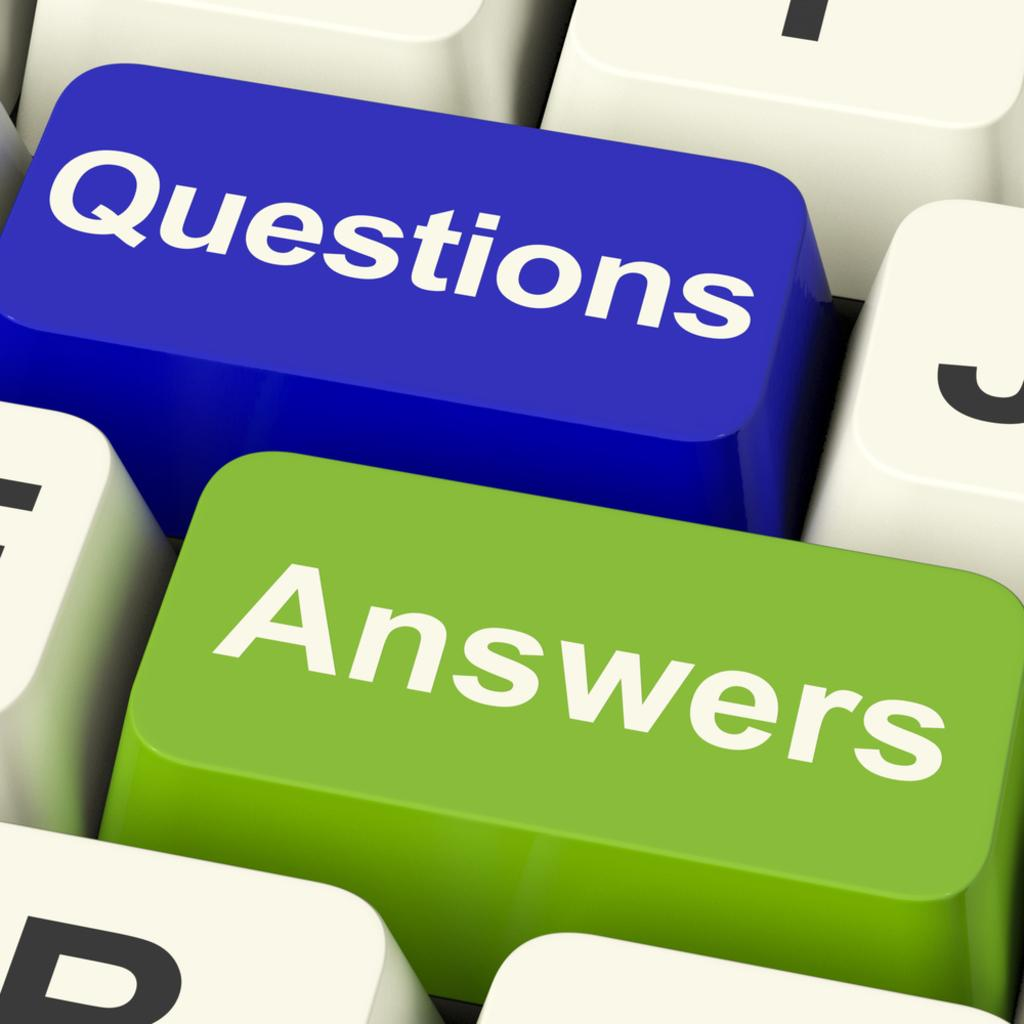<image>
Provide a brief description of the given image. The keyboard keys are showing the words questions and answers. 